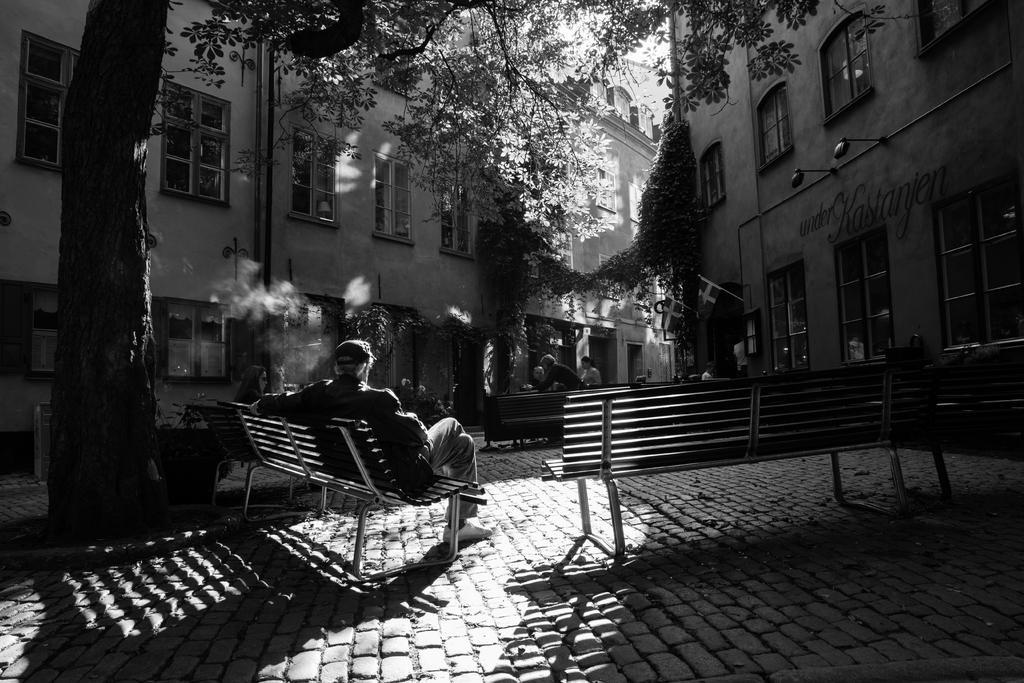Describe this image in one or two sentences. A man is sitting in the chair on the left it's a tree behind it's a building. 